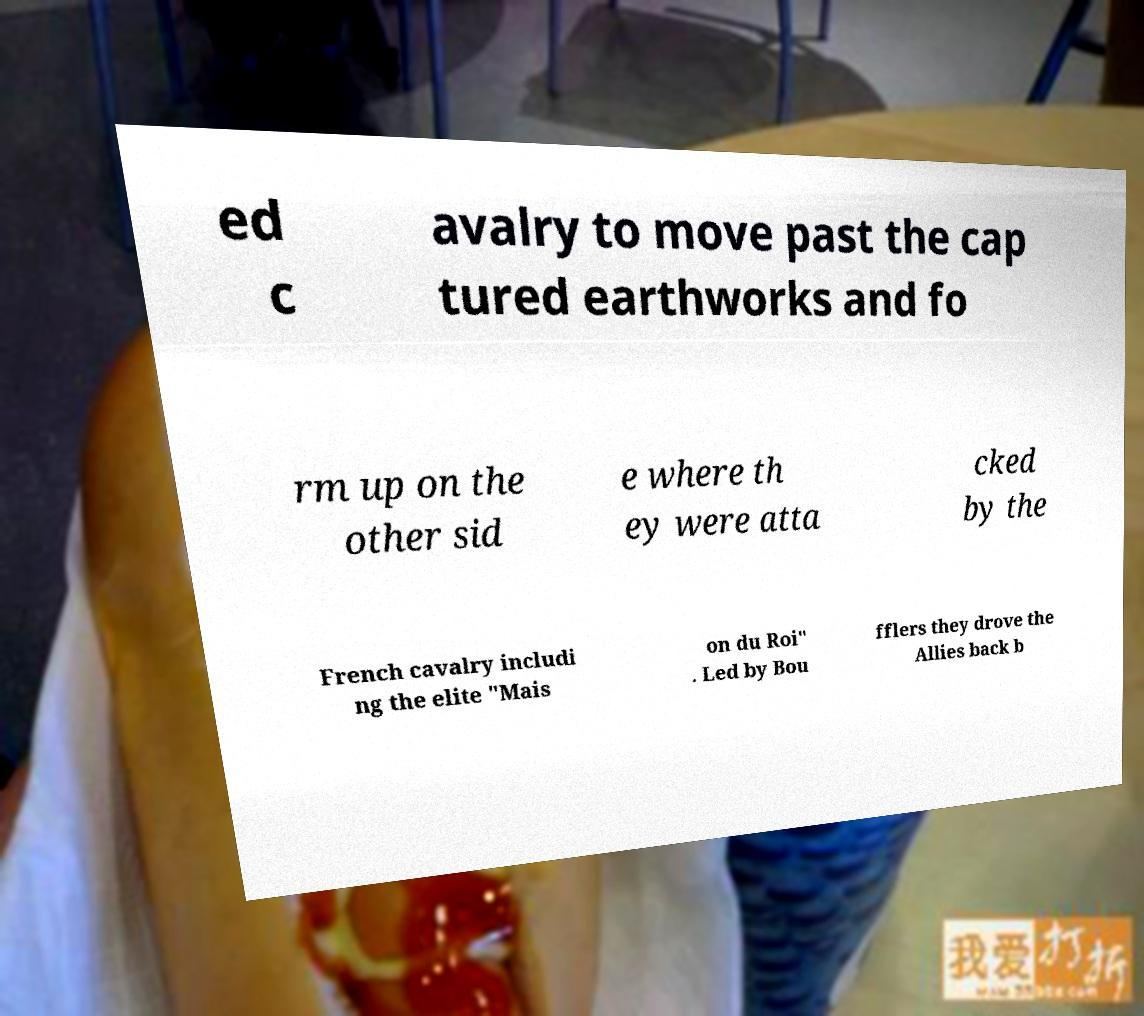Please read and relay the text visible in this image. What does it say? ed c avalry to move past the cap tured earthworks and fo rm up on the other sid e where th ey were atta cked by the French cavalry includi ng the elite "Mais on du Roi" . Led by Bou fflers they drove the Allies back b 